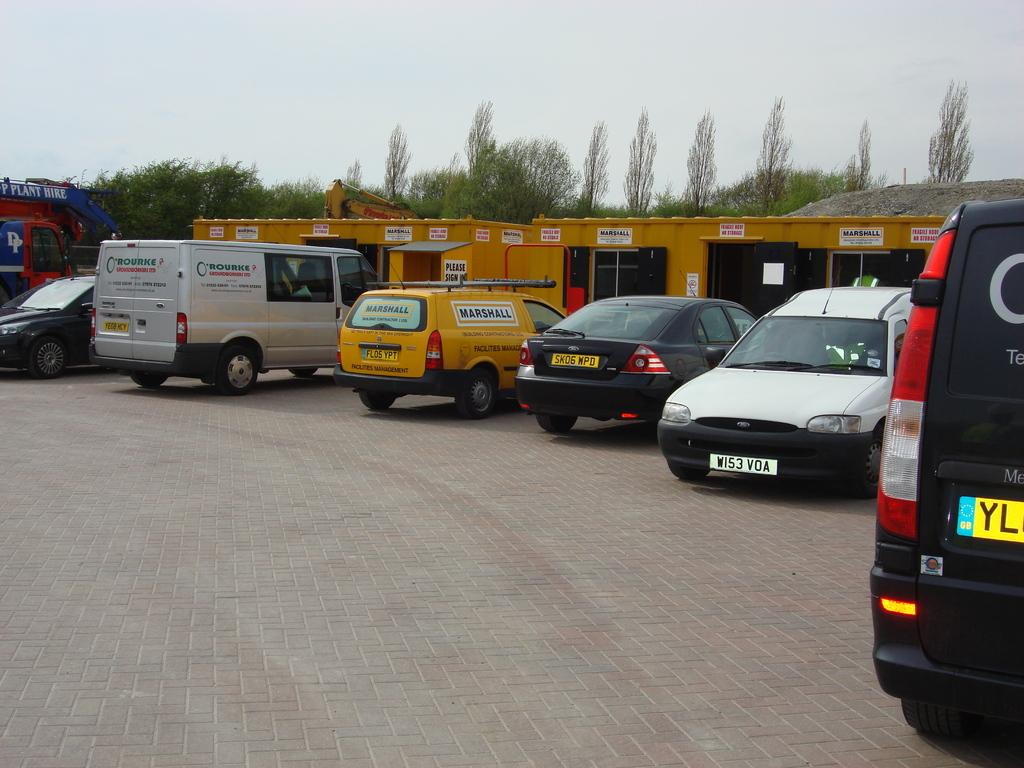<image>
Offer a succinct explanation of the picture presented. A row of vehicles are parked by yellow sipping containers that say Marshall. 